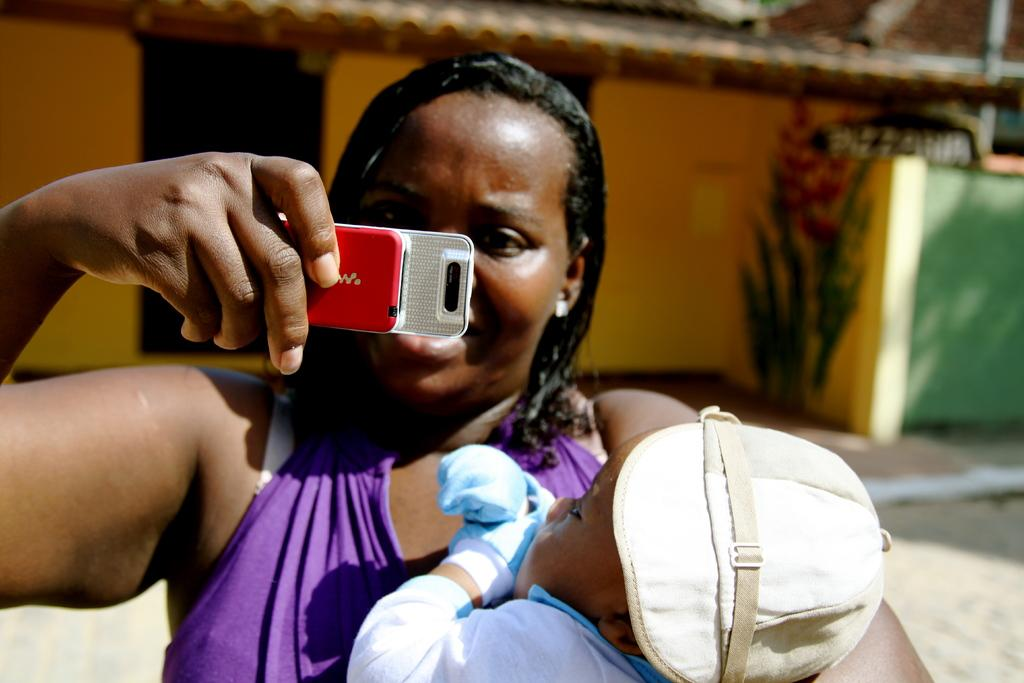Who is the main subject in the image? There is a woman in the image. What is the woman doing in the image? The woman is standing and holding a baby in her hand. What other object can be seen in the image? There is a mobile phone in the image. What type of impulse can be seen affecting the woman's ear in the image? There is no impulse affecting the woman's ear in the image. Can you describe the woman's self in the image? The image does not provide information about the woman's self or her emotions. 